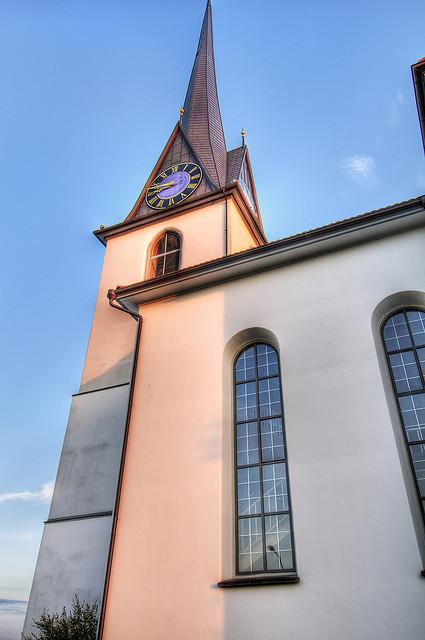Is this a modern building?
Keep it brief. No. What is in the sky?
Short answer required. Clouds. What is the steeple shaped like?
Keep it brief. Triangle. What time does the clock say?
Short answer required. 8:45. Is this a church?
Answer briefly. Yes. Does the yellow color at the base of the building look funny?
Give a very brief answer. No. 